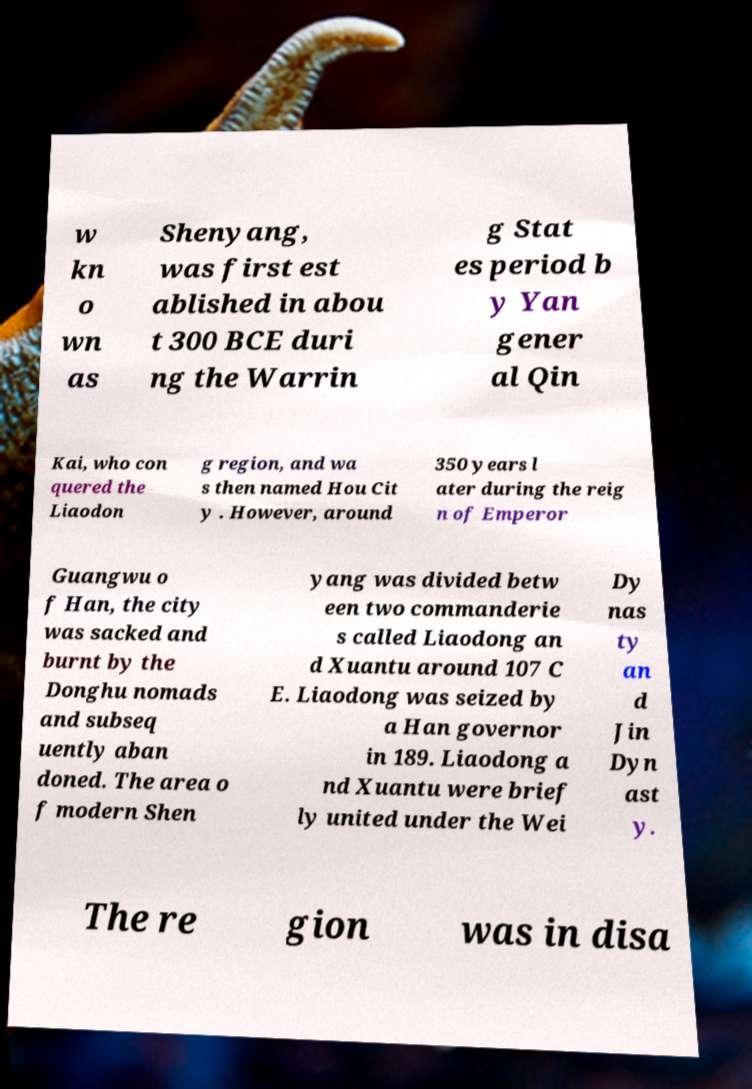Can you read and provide the text displayed in the image?This photo seems to have some interesting text. Can you extract and type it out for me? w kn o wn as Shenyang, was first est ablished in abou t 300 BCE duri ng the Warrin g Stat es period b y Yan gener al Qin Kai, who con quered the Liaodon g region, and wa s then named Hou Cit y . However, around 350 years l ater during the reig n of Emperor Guangwu o f Han, the city was sacked and burnt by the Donghu nomads and subseq uently aban doned. The area o f modern Shen yang was divided betw een two commanderie s called Liaodong an d Xuantu around 107 C E. Liaodong was seized by a Han governor in 189. Liaodong a nd Xuantu were brief ly united under the Wei Dy nas ty an d Jin Dyn ast y. The re gion was in disa 